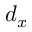<formula> <loc_0><loc_0><loc_500><loc_500>d _ { x }</formula> 